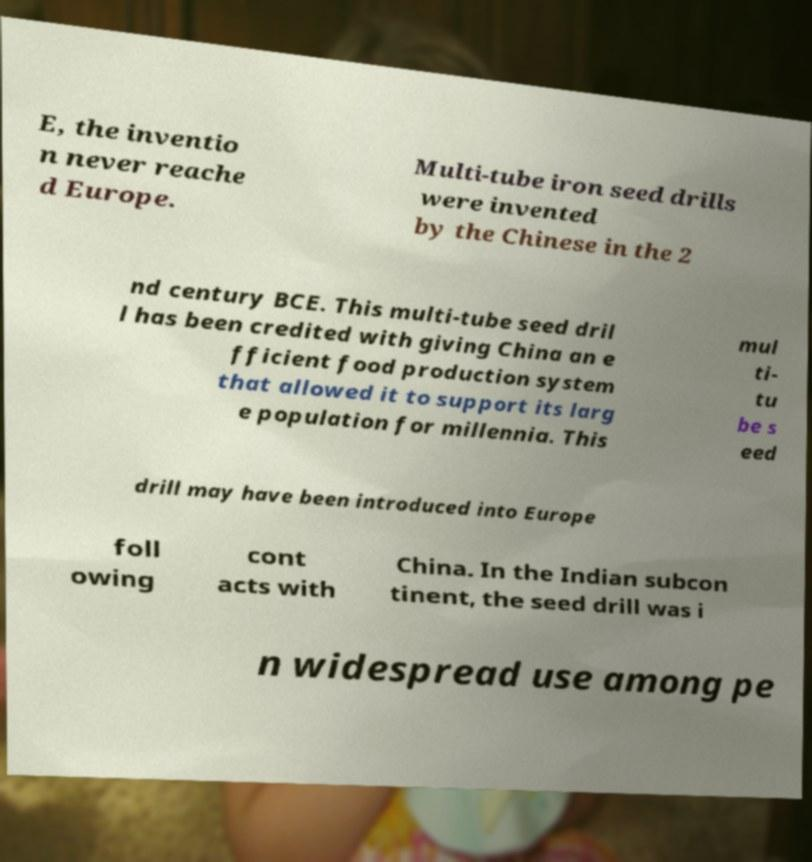There's text embedded in this image that I need extracted. Can you transcribe it verbatim? E, the inventio n never reache d Europe. Multi-tube iron seed drills were invented by the Chinese in the 2 nd century BCE. This multi-tube seed dril l has been credited with giving China an e fficient food production system that allowed it to support its larg e population for millennia. This mul ti- tu be s eed drill may have been introduced into Europe foll owing cont acts with China. In the Indian subcon tinent, the seed drill was i n widespread use among pe 